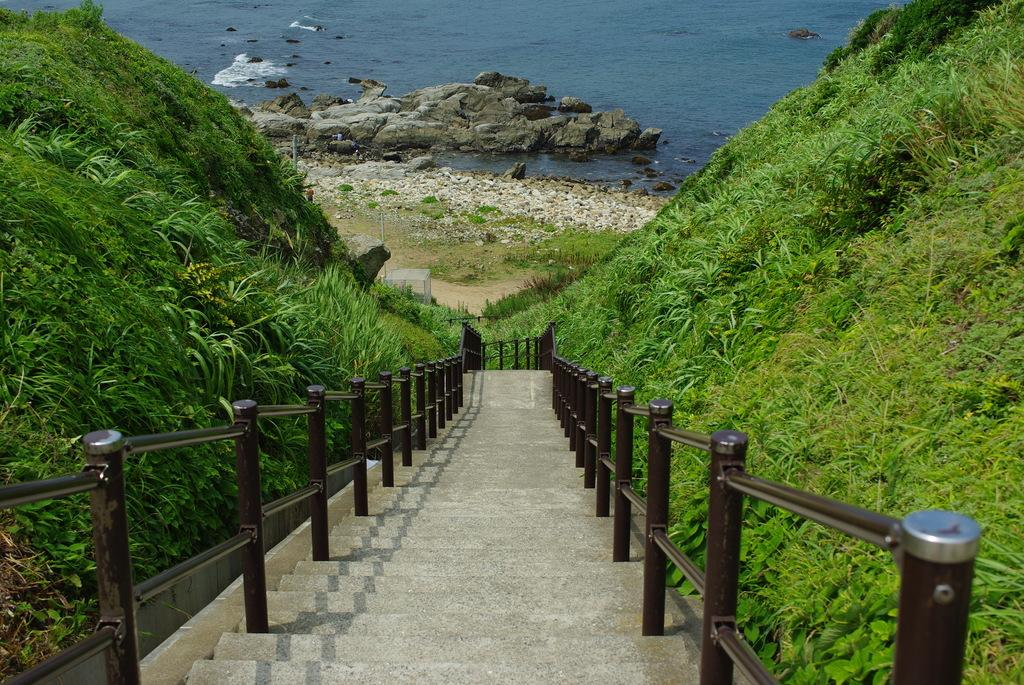What type of structure is present in the image? There are stairs in the image. What feature is present alongside the stairs? There is a railing in the image. What type of natural environment is visible in the image? There is grass in the image. What type of ground surface can be seen in the image? There are stones and rocks in the image. What body of water is visible in the image? There is water visible in the image. What type of umbrella is being used to protect the grass from the heat in the image? There is no umbrella present in the image, and the grass is not being protected from any heat source. 